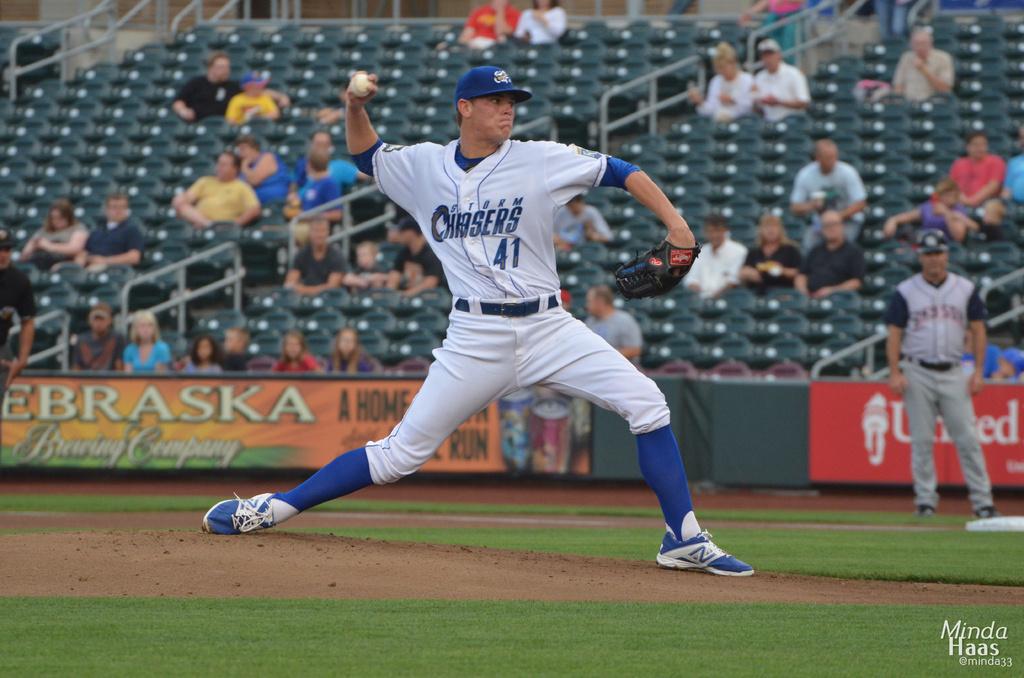Is that orange sign by the nebraska bearing company?
Give a very brief answer. Yes. 